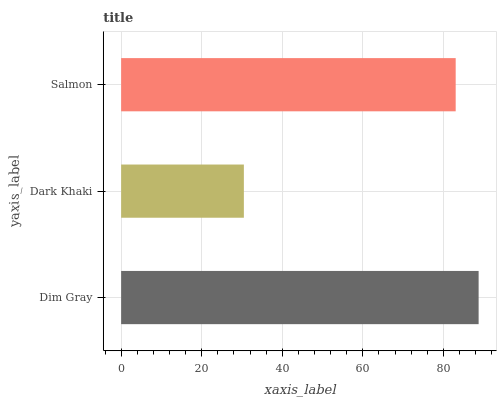Is Dark Khaki the minimum?
Answer yes or no. Yes. Is Dim Gray the maximum?
Answer yes or no. Yes. Is Salmon the minimum?
Answer yes or no. No. Is Salmon the maximum?
Answer yes or no. No. Is Salmon greater than Dark Khaki?
Answer yes or no. Yes. Is Dark Khaki less than Salmon?
Answer yes or no. Yes. Is Dark Khaki greater than Salmon?
Answer yes or no. No. Is Salmon less than Dark Khaki?
Answer yes or no. No. Is Salmon the high median?
Answer yes or no. Yes. Is Salmon the low median?
Answer yes or no. Yes. Is Dim Gray the high median?
Answer yes or no. No. Is Dark Khaki the low median?
Answer yes or no. No. 